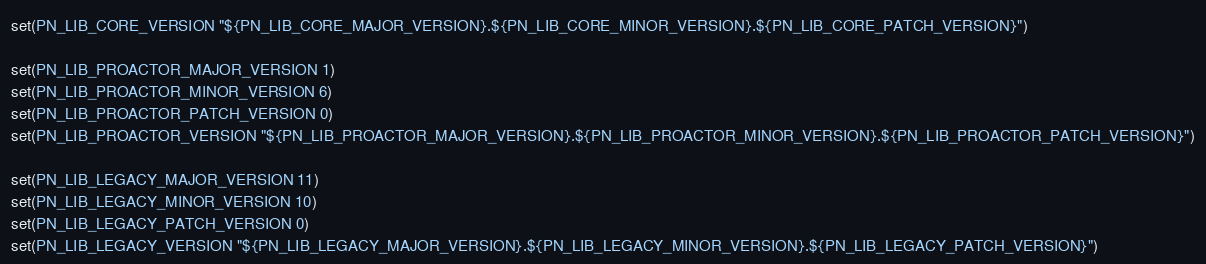<code> <loc_0><loc_0><loc_500><loc_500><_CMake_>set(PN_LIB_CORE_VERSION "${PN_LIB_CORE_MAJOR_VERSION}.${PN_LIB_CORE_MINOR_VERSION}.${PN_LIB_CORE_PATCH_VERSION}")

set(PN_LIB_PROACTOR_MAJOR_VERSION 1)
set(PN_LIB_PROACTOR_MINOR_VERSION 6)
set(PN_LIB_PROACTOR_PATCH_VERSION 0)
set(PN_LIB_PROACTOR_VERSION "${PN_LIB_PROACTOR_MAJOR_VERSION}.${PN_LIB_PROACTOR_MINOR_VERSION}.${PN_LIB_PROACTOR_PATCH_VERSION}")

set(PN_LIB_LEGACY_MAJOR_VERSION 11)
set(PN_LIB_LEGACY_MINOR_VERSION 10)
set(PN_LIB_LEGACY_PATCH_VERSION 0)
set(PN_LIB_LEGACY_VERSION "${PN_LIB_LEGACY_MAJOR_VERSION}.${PN_LIB_LEGACY_MINOR_VERSION}.${PN_LIB_LEGACY_PATCH_VERSION}")
</code> 